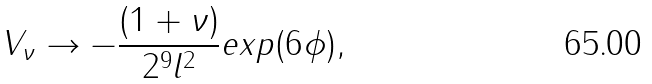<formula> <loc_0><loc_0><loc_500><loc_500>V _ { \nu } \rightarrow - \frac { ( 1 + \nu ) } { 2 ^ { 9 } l ^ { 2 } } e x p ( 6 \phi ) ,</formula> 